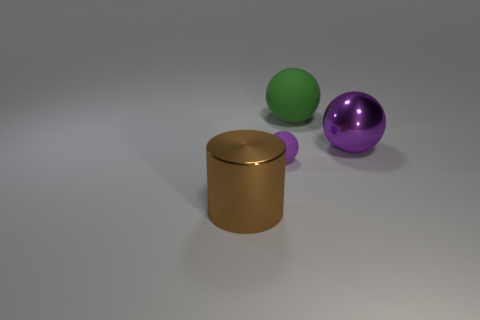Subtract all purple balls. How many balls are left? 1 Subtract all purple spheres. How many spheres are left? 1 Subtract all balls. How many objects are left? 1 Subtract 1 cylinders. How many cylinders are left? 0 Add 3 brown shiny cylinders. How many objects exist? 7 Subtract 2 purple balls. How many objects are left? 2 Subtract all gray balls. Subtract all red cylinders. How many balls are left? 3 Subtract all yellow spheres. How many blue cylinders are left? 0 Subtract all green metallic cubes. Subtract all purple shiny spheres. How many objects are left? 3 Add 1 purple matte things. How many purple matte things are left? 2 